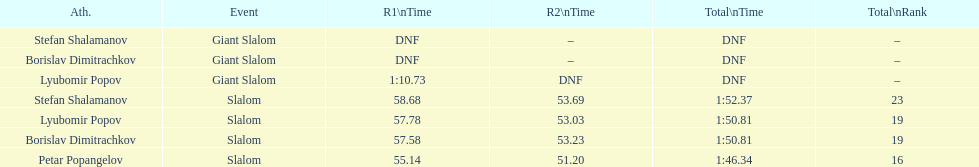What is the ranking number of stefan shalamanov in the slalom event? 23. 